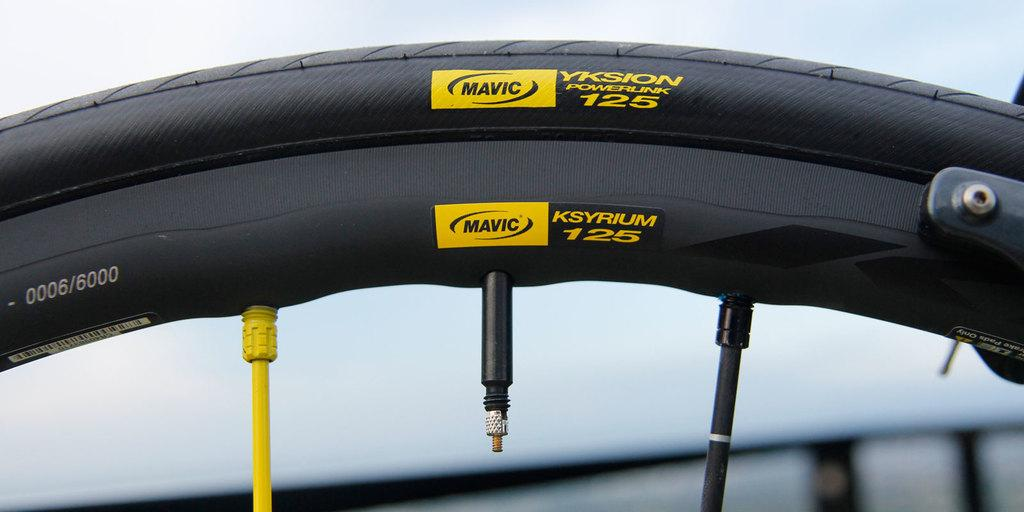What is the main object in the image? There is a wheel in the image. Can you describe the background of the image? The background of the image is blurry. How many goldfish can be seen swimming in the background of the image? There are no goldfish present in the image; the background is blurry. 